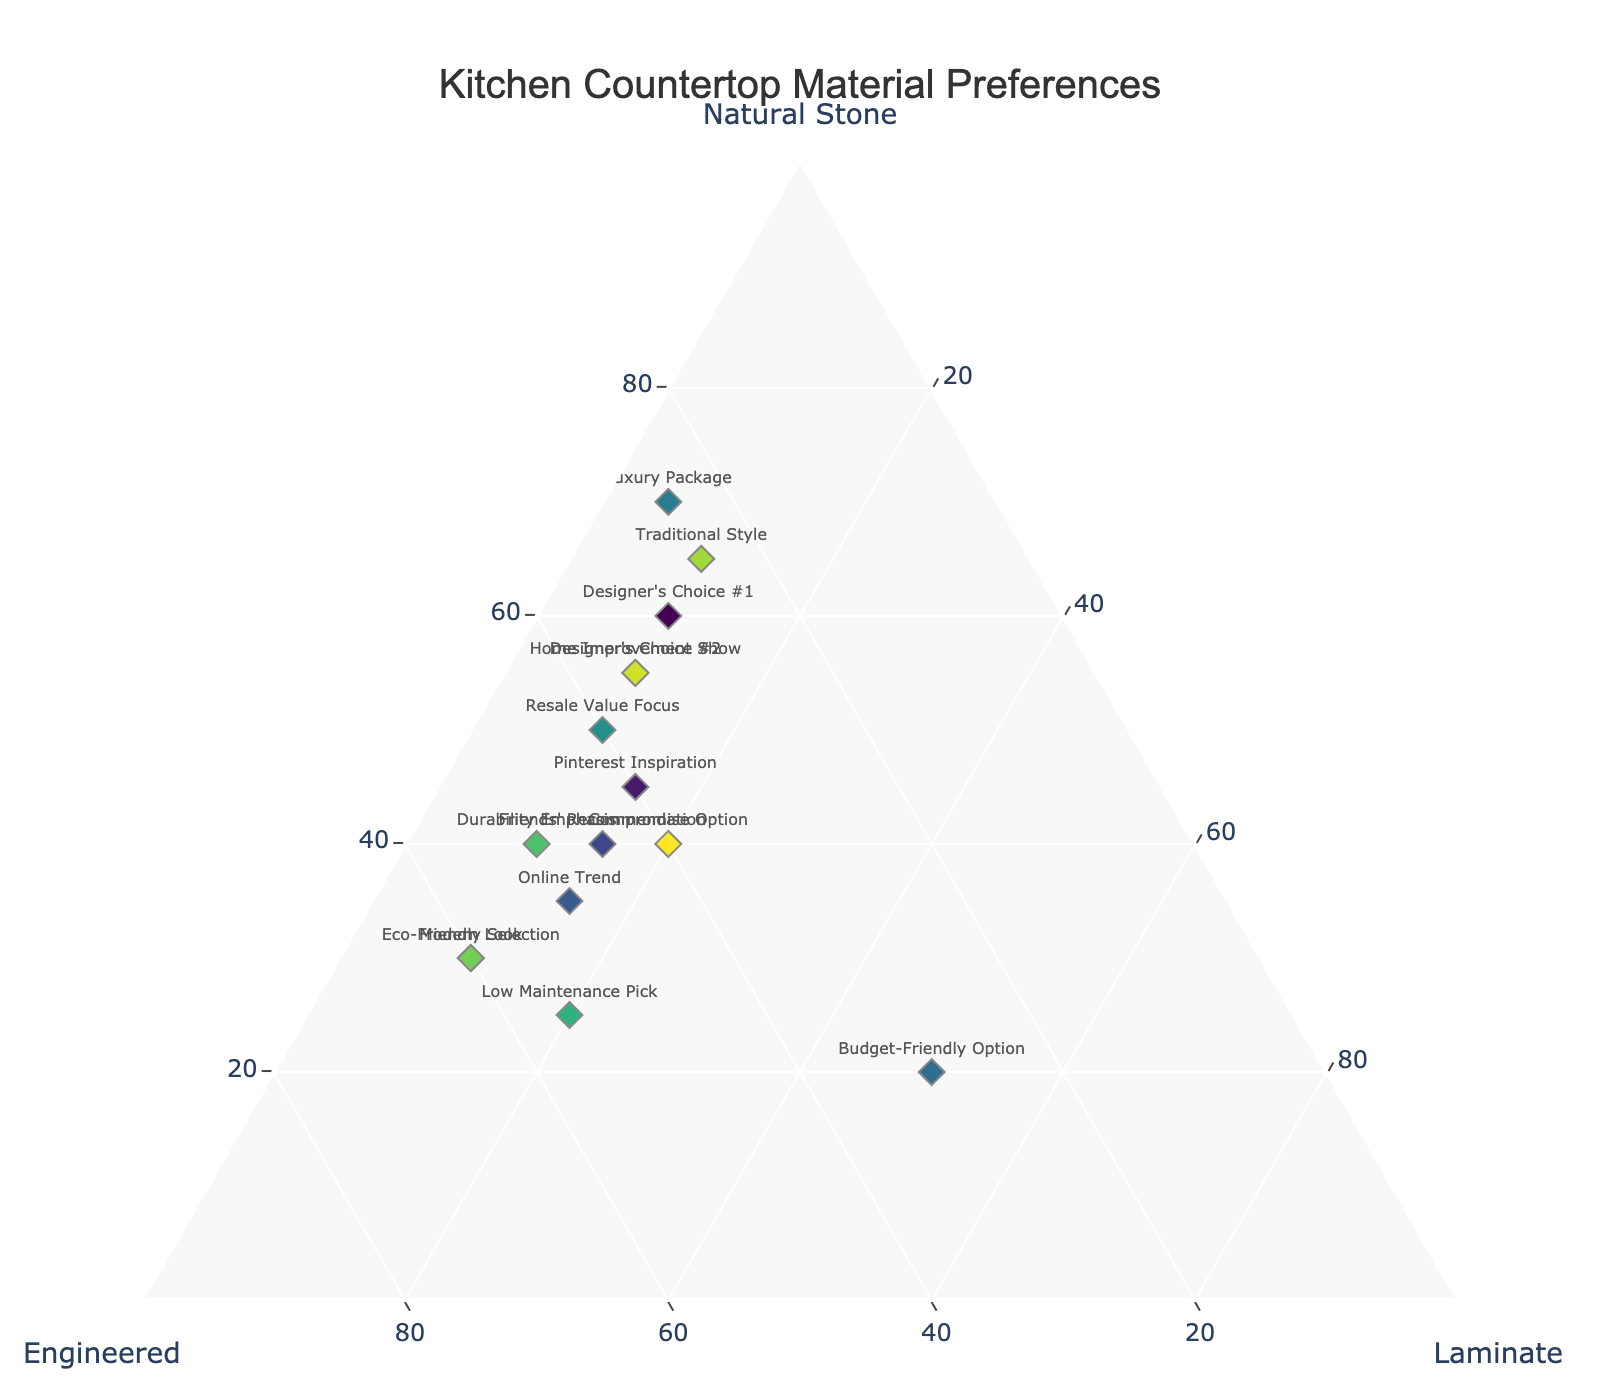What is the title of the figure? The title can be found at the top of the figure.
Answer: Kitchen Countertop Material Preferences Which data point represents the most popular choice for "Natural Stone"? The data point with the highest percentage for "Natural Stone" on the plot corresponds to "Luxury Package" which has 70%.
Answer: Luxury Package What are the percentages for "Engineered" in the "Eco-Friendly Selection"? Locate "Eco-Friendly Selection" on the plot and check the "Engineered" axis.
Answer: 60% Which option is positioned closest to the "Laminate" vertex? Locate the data point nearest the "Laminate" vertex, representing the highest percentage for Laminate, which is "Budget-Friendly Option" at 50%.
Answer: Budget-Friendly Option Compare the "Engineered" percentage between "Friends' Recommendation" and "Online Trend." Which one is higher? Locate both points and compare their positions along the "Engineered" axis; "Online Trend" is higher with 50% compared to "Friends' Recommendation" at 45%.
Answer: Online Trend What is the average percentage of "Natural Stone" for "Designer's Choice #1" and "Designer's Choice #2"? Add the percentages of "Natural Stone" for both options (60% + 55%) and divide by 2.
Answer: 57.5% Which option is balanced equally between "Natural Stone" and "Engineered"? Find the data point where the percentages of "Natural Stone" and "Engineered" are the same, which is "Compromise Option" with 40% each.
Answer: Compromise Option Identify the selection with the highest percentage for "Engineered" and describe the other two percentages. The maximum "Engineered" percentage is for "Eco-Friendly Selection" at 60%. Its other percentages are 30% "Natural Stone" and 10% "Laminate".
Answer: 30% Natural Stone, 10% Laminate Which option considers "Resale Value Focus" and how does it compare to "Home Improvement Show" in terms of "Engineered" material? Find the "Resale Value Focus" and "Home Improvement Show" on the plot and compare their "Engineered" percentages; both are at 40%.
Answer: Equal at 40% 